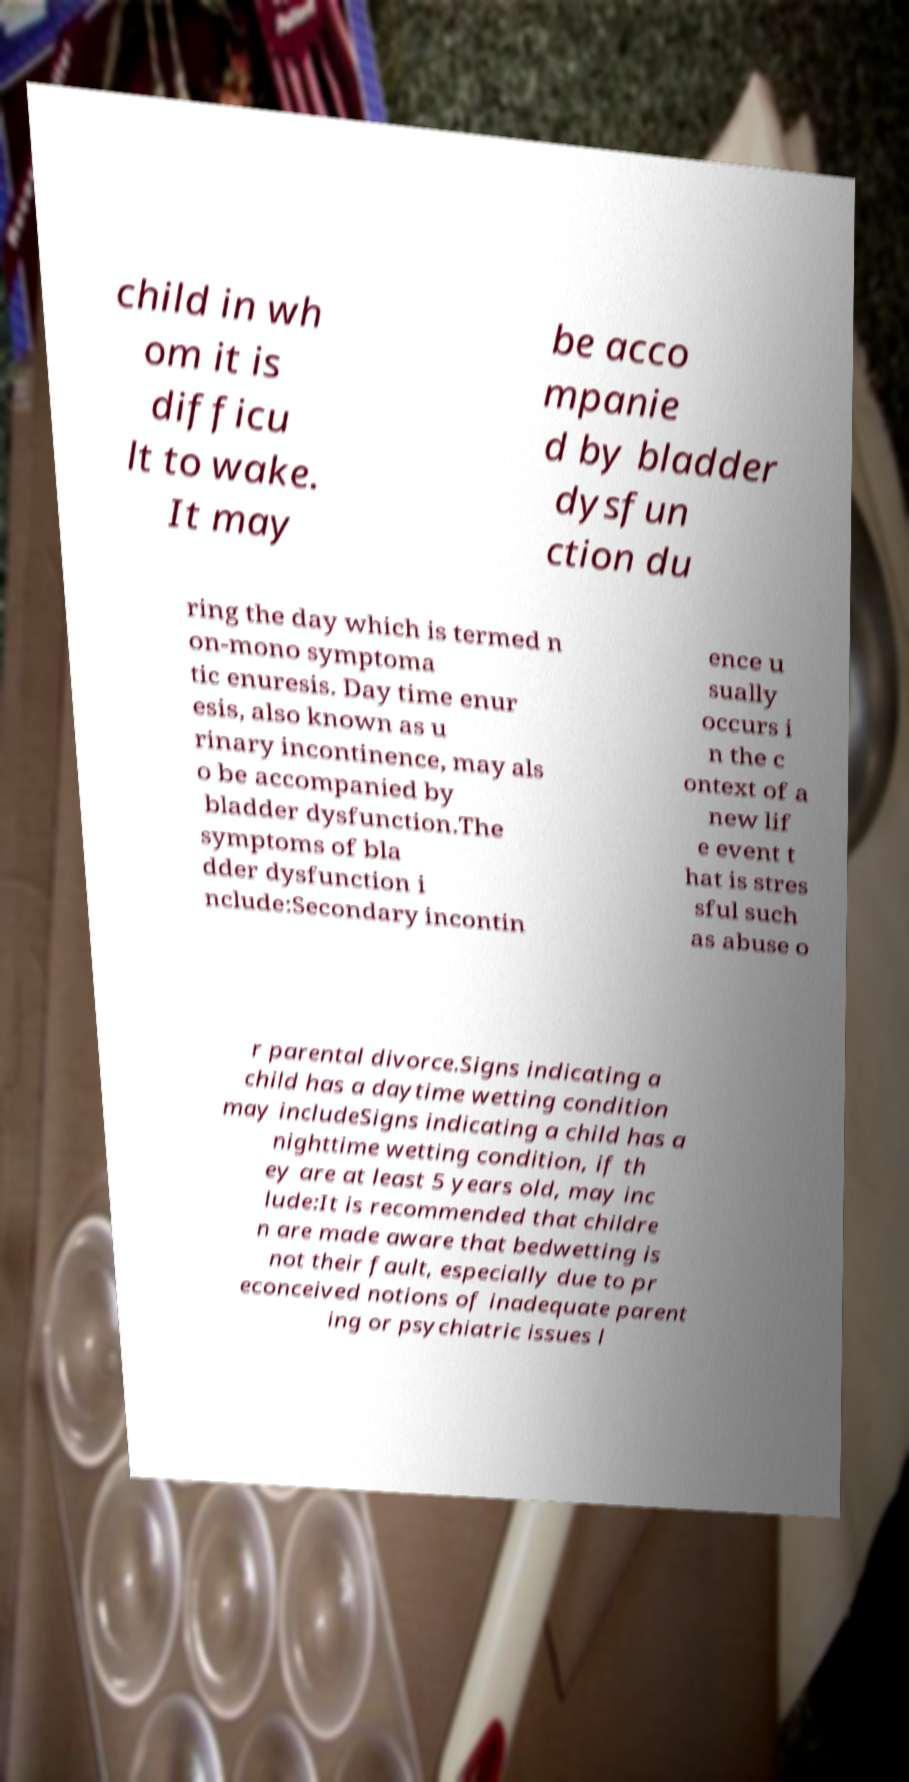I need the written content from this picture converted into text. Can you do that? child in wh om it is difficu lt to wake. It may be acco mpanie d by bladder dysfun ction du ring the day which is termed n on-mono symptoma tic enuresis. Day time enur esis, also known as u rinary incontinence, may als o be accompanied by bladder dysfunction.The symptoms of bla dder dysfunction i nclude:Secondary incontin ence u sually occurs i n the c ontext of a new lif e event t hat is stres sful such as abuse o r parental divorce.Signs indicating a child has a daytime wetting condition may includeSigns indicating a child has a nighttime wetting condition, if th ey are at least 5 years old, may inc lude:It is recommended that childre n are made aware that bedwetting is not their fault, especially due to pr econceived notions of inadequate parent ing or psychiatric issues l 